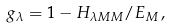Convert formula to latex. <formula><loc_0><loc_0><loc_500><loc_500>g _ { \lambda } = 1 - H _ { \lambda M M } / E _ { M } \, ,</formula> 